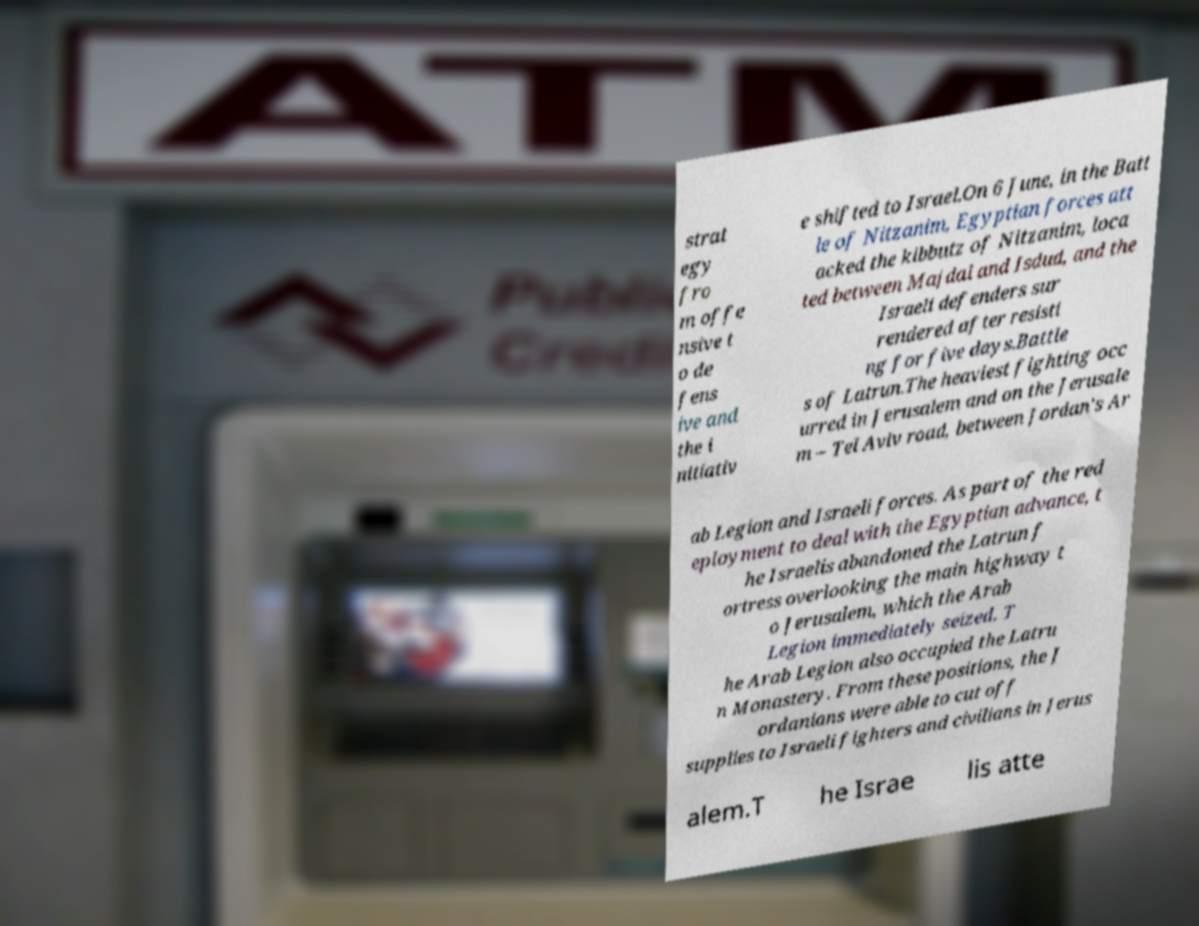Could you assist in decoding the text presented in this image and type it out clearly? strat egy fro m offe nsive t o de fens ive and the i nitiativ e shifted to Israel.On 6 June, in the Batt le of Nitzanim, Egyptian forces att acked the kibbutz of Nitzanim, loca ted between Majdal and Isdud, and the Israeli defenders sur rendered after resisti ng for five days.Battle s of Latrun.The heaviest fighting occ urred in Jerusalem and on the Jerusale m – Tel Aviv road, between Jordan's Ar ab Legion and Israeli forces. As part of the red eployment to deal with the Egyptian advance, t he Israelis abandoned the Latrun f ortress overlooking the main highway t o Jerusalem, which the Arab Legion immediately seized. T he Arab Legion also occupied the Latru n Monastery. From these positions, the J ordanians were able to cut off supplies to Israeli fighters and civilians in Jerus alem.T he Israe lis atte 